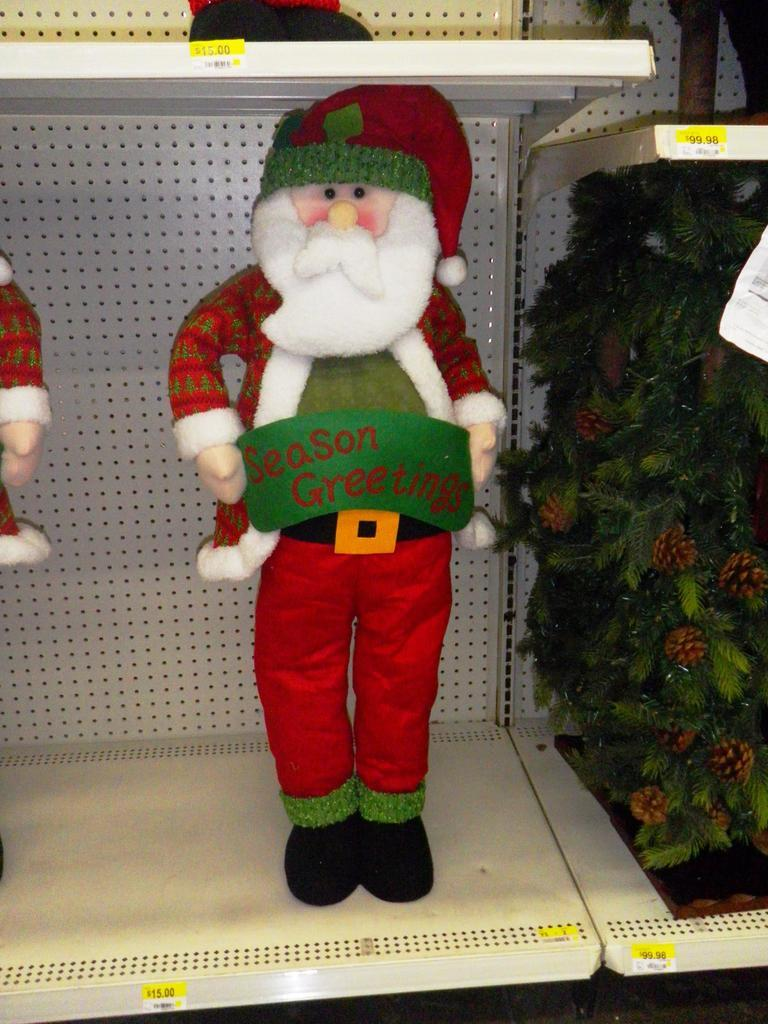<image>
Offer a succinct explanation of the picture presented. A standing Santa Claus figurine with Season's Greetings on a sign that it is holding. 